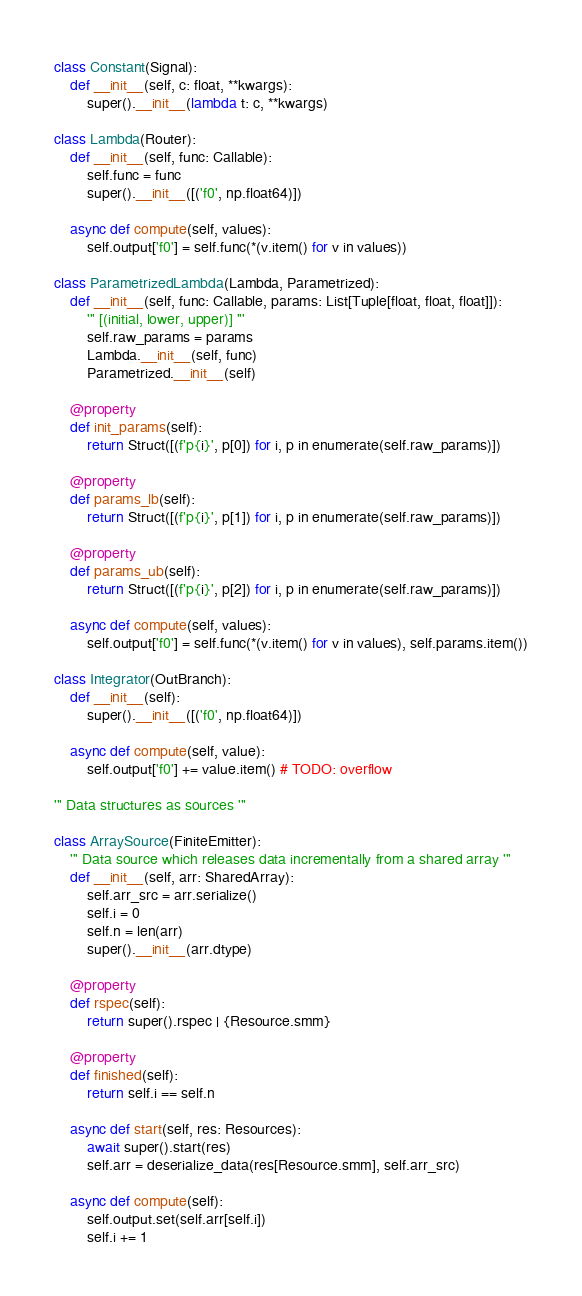<code> <loc_0><loc_0><loc_500><loc_500><_Python_>
class Constant(Signal):
	def __init__(self, c: float, **kwargs):
		super().__init__(lambda t: c, **kwargs)

class Lambda(Router):
	def __init__(self, func: Callable):
		self.func = func
		super().__init__([('f0', np.float64)])

	async def compute(self, values):
		self.output['f0'] = self.func(*(v.item() for v in values))

class ParametrizedLambda(Lambda, Parametrized):
	def __init__(self, func: Callable, params: List[Tuple[float, float, float]]):
		''' [(initial, lower, upper)] ''' 
		self.raw_params = params
		Lambda.__init__(self, func)
		Parametrized.__init__(self)

	@property
	def init_params(self):
		return Struct([(f'p{i}', p[0]) for i, p in enumerate(self.raw_params)])

	@property
	def params_lb(self):
		return Struct([(f'p{i}', p[1]) for i, p in enumerate(self.raw_params)])
	
	@property
	def params_ub(self):
		return Struct([(f'p{i}', p[2]) for i, p in enumerate(self.raw_params)])

	async def compute(self, values):
		self.output['f0'] = self.func(*(v.item() for v in values), self.params.item())

class Integrator(OutBranch):
	def __init__(self):
		super().__init__([('f0', np.float64)])

	async def compute(self, value):
		self.output['f0'] += value.item() # TODO: overflow

''' Data structures as sources ''' 

class ArraySource(FiniteEmitter):
	''' Data source which releases data incrementally from a shared array ''' 
	def __init__(self, arr: SharedArray):
		self.arr_src = arr.serialize()
		self.i = 0
		self.n = len(arr)
		super().__init__(arr.dtype)

	@property 
	def rspec(self):
		return super().rspec | {Resource.smm}

	@property
	def finished(self):
		return self.i == self.n		

	async def start(self, res: Resources):
		await super().start(res)
		self.arr = deserialize_data(res[Resource.smm], self.arr_src)

	async def compute(self):
		self.output.set(self.arr[self.i]) 
		self.i += 1</code> 